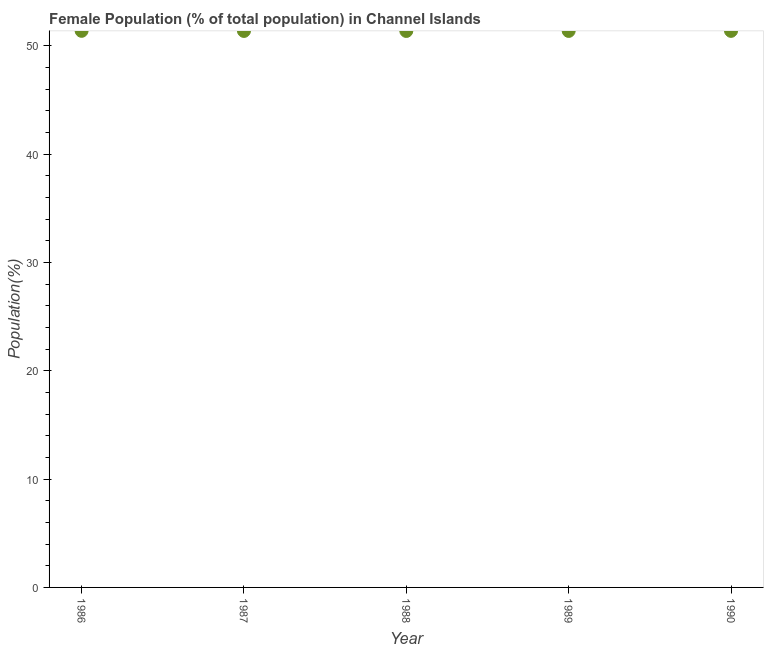What is the female population in 1990?
Give a very brief answer. 51.38. Across all years, what is the maximum female population?
Offer a terse response. 51.38. Across all years, what is the minimum female population?
Give a very brief answer. 51.37. In which year was the female population maximum?
Provide a succinct answer. 1986. What is the sum of the female population?
Offer a very short reply. 256.87. What is the difference between the female population in 1988 and 1989?
Provide a short and direct response. -0. What is the average female population per year?
Your answer should be compact. 51.37. What is the median female population?
Your answer should be very brief. 51.37. Do a majority of the years between 1986 and 1990 (inclusive) have female population greater than 36 %?
Make the answer very short. Yes. What is the ratio of the female population in 1987 to that in 1990?
Your response must be concise. 1. Is the difference between the female population in 1986 and 1989 greater than the difference between any two years?
Provide a short and direct response. No. What is the difference between the highest and the second highest female population?
Your response must be concise. 0. Is the sum of the female population in 1986 and 1989 greater than the maximum female population across all years?
Your response must be concise. Yes. What is the difference between the highest and the lowest female population?
Offer a very short reply. 0.01. Does the female population monotonically increase over the years?
Keep it short and to the point. No. How many dotlines are there?
Offer a terse response. 1. How many years are there in the graph?
Keep it short and to the point. 5. Are the values on the major ticks of Y-axis written in scientific E-notation?
Make the answer very short. No. What is the title of the graph?
Offer a terse response. Female Population (% of total population) in Channel Islands. What is the label or title of the Y-axis?
Provide a short and direct response. Population(%). What is the Population(%) in 1986?
Give a very brief answer. 51.38. What is the Population(%) in 1987?
Your response must be concise. 51.37. What is the Population(%) in 1988?
Give a very brief answer. 51.37. What is the Population(%) in 1989?
Offer a terse response. 51.37. What is the Population(%) in 1990?
Offer a terse response. 51.38. What is the difference between the Population(%) in 1986 and 1987?
Make the answer very short. 0.01. What is the difference between the Population(%) in 1986 and 1988?
Keep it short and to the point. 0.01. What is the difference between the Population(%) in 1986 and 1989?
Your response must be concise. 0.01. What is the difference between the Population(%) in 1986 and 1990?
Give a very brief answer. 0. What is the difference between the Population(%) in 1987 and 1988?
Provide a short and direct response. 0. What is the difference between the Population(%) in 1987 and 1989?
Offer a very short reply. -0. What is the difference between the Population(%) in 1987 and 1990?
Ensure brevity in your answer.  -0.01. What is the difference between the Population(%) in 1988 and 1989?
Provide a short and direct response. -0. What is the difference between the Population(%) in 1988 and 1990?
Make the answer very short. -0.01. What is the difference between the Population(%) in 1989 and 1990?
Provide a short and direct response. -0.01. What is the ratio of the Population(%) in 1986 to that in 1990?
Ensure brevity in your answer.  1. What is the ratio of the Population(%) in 1987 to that in 1990?
Provide a short and direct response. 1. What is the ratio of the Population(%) in 1988 to that in 1990?
Keep it short and to the point. 1. What is the ratio of the Population(%) in 1989 to that in 1990?
Offer a very short reply. 1. 